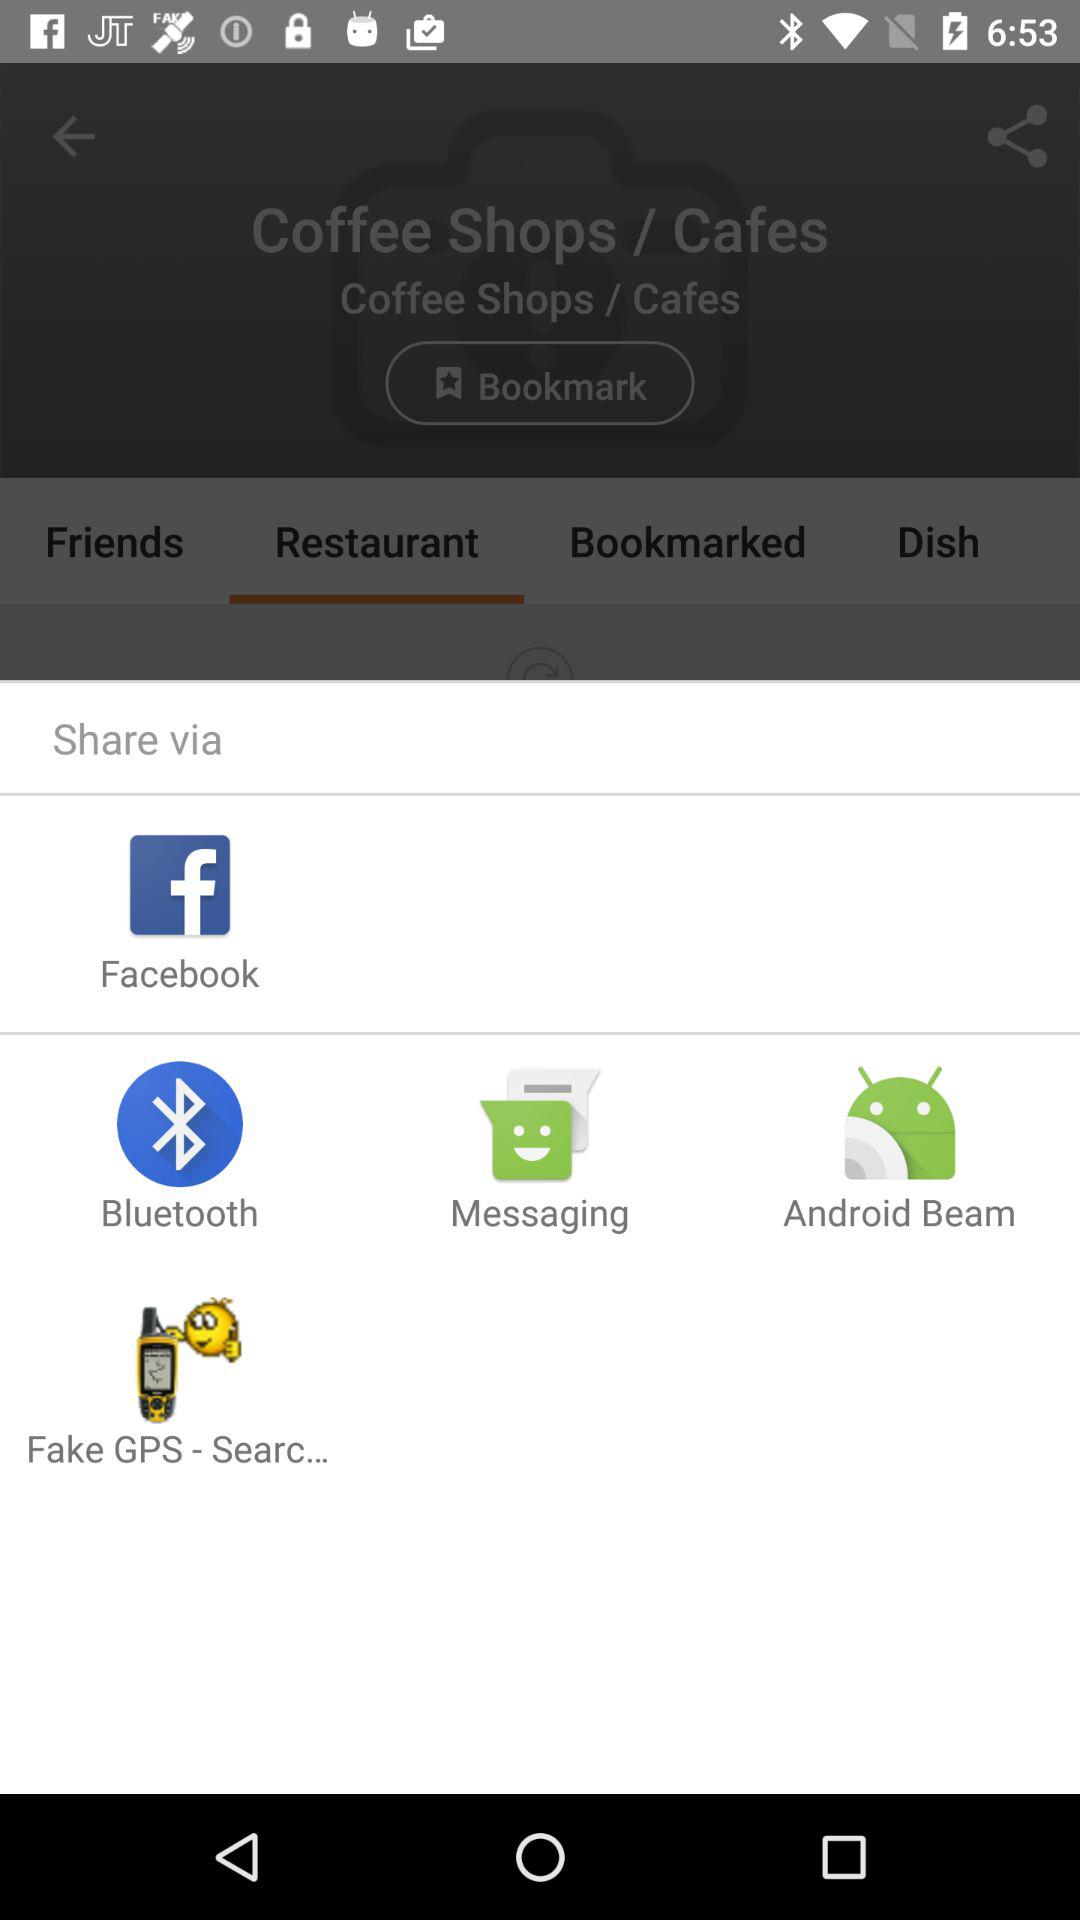How many items are in "Dish"?
When the provided information is insufficient, respond with <no answer>. <no answer> 